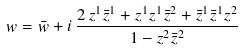Convert formula to latex. <formula><loc_0><loc_0><loc_500><loc_500>w = \bar { w } + i \, \frac { 2 \, z ^ { 1 } \bar { z } ^ { 1 } + z ^ { 1 } z ^ { 1 } \bar { z } ^ { 2 } + \bar { z } ^ { 1 } \bar { z } ^ { 1 } z ^ { 2 } } { 1 - z ^ { 2 } \bar { z } ^ { 2 } }</formula> 